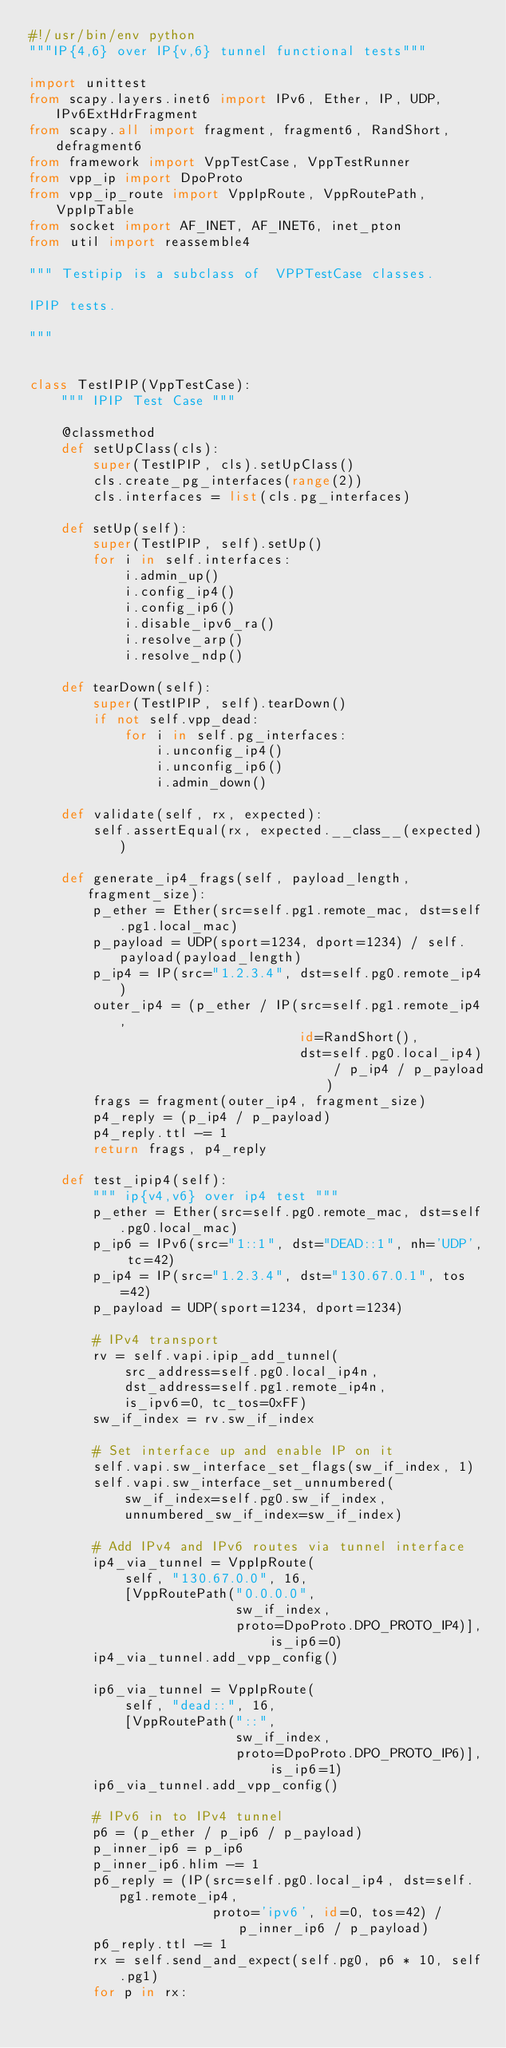<code> <loc_0><loc_0><loc_500><loc_500><_Python_>#!/usr/bin/env python
"""IP{4,6} over IP{v,6} tunnel functional tests"""

import unittest
from scapy.layers.inet6 import IPv6, Ether, IP, UDP, IPv6ExtHdrFragment
from scapy.all import fragment, fragment6, RandShort, defragment6
from framework import VppTestCase, VppTestRunner
from vpp_ip import DpoProto
from vpp_ip_route import VppIpRoute, VppRoutePath, VppIpTable
from socket import AF_INET, AF_INET6, inet_pton
from util import reassemble4

""" Testipip is a subclass of  VPPTestCase classes.

IPIP tests.

"""


class TestIPIP(VppTestCase):
    """ IPIP Test Case """

    @classmethod
    def setUpClass(cls):
        super(TestIPIP, cls).setUpClass()
        cls.create_pg_interfaces(range(2))
        cls.interfaces = list(cls.pg_interfaces)

    def setUp(self):
        super(TestIPIP, self).setUp()
        for i in self.interfaces:
            i.admin_up()
            i.config_ip4()
            i.config_ip6()
            i.disable_ipv6_ra()
            i.resolve_arp()
            i.resolve_ndp()

    def tearDown(self):
        super(TestIPIP, self).tearDown()
        if not self.vpp_dead:
            for i in self.pg_interfaces:
                i.unconfig_ip4()
                i.unconfig_ip6()
                i.admin_down()

    def validate(self, rx, expected):
        self.assertEqual(rx, expected.__class__(expected))

    def generate_ip4_frags(self, payload_length, fragment_size):
        p_ether = Ether(src=self.pg1.remote_mac, dst=self.pg1.local_mac)
        p_payload = UDP(sport=1234, dport=1234) / self.payload(payload_length)
        p_ip4 = IP(src="1.2.3.4", dst=self.pg0.remote_ip4)
        outer_ip4 = (p_ether / IP(src=self.pg1.remote_ip4,
                                  id=RandShort(),
                                  dst=self.pg0.local_ip4) / p_ip4 / p_payload)
        frags = fragment(outer_ip4, fragment_size)
        p4_reply = (p_ip4 / p_payload)
        p4_reply.ttl -= 1
        return frags, p4_reply

    def test_ipip4(self):
        """ ip{v4,v6} over ip4 test """
        p_ether = Ether(src=self.pg0.remote_mac, dst=self.pg0.local_mac)
        p_ip6 = IPv6(src="1::1", dst="DEAD::1", nh='UDP', tc=42)
        p_ip4 = IP(src="1.2.3.4", dst="130.67.0.1", tos=42)
        p_payload = UDP(sport=1234, dport=1234)

        # IPv4 transport
        rv = self.vapi.ipip_add_tunnel(
            src_address=self.pg0.local_ip4n,
            dst_address=self.pg1.remote_ip4n,
            is_ipv6=0, tc_tos=0xFF)
        sw_if_index = rv.sw_if_index

        # Set interface up and enable IP on it
        self.vapi.sw_interface_set_flags(sw_if_index, 1)
        self.vapi.sw_interface_set_unnumbered(
            sw_if_index=self.pg0.sw_if_index,
            unnumbered_sw_if_index=sw_if_index)

        # Add IPv4 and IPv6 routes via tunnel interface
        ip4_via_tunnel = VppIpRoute(
            self, "130.67.0.0", 16,
            [VppRoutePath("0.0.0.0",
                          sw_if_index,
                          proto=DpoProto.DPO_PROTO_IP4)], is_ip6=0)
        ip4_via_tunnel.add_vpp_config()

        ip6_via_tunnel = VppIpRoute(
            self, "dead::", 16,
            [VppRoutePath("::",
                          sw_if_index,
                          proto=DpoProto.DPO_PROTO_IP6)], is_ip6=1)
        ip6_via_tunnel.add_vpp_config()

        # IPv6 in to IPv4 tunnel
        p6 = (p_ether / p_ip6 / p_payload)
        p_inner_ip6 = p_ip6
        p_inner_ip6.hlim -= 1
        p6_reply = (IP(src=self.pg0.local_ip4, dst=self.pg1.remote_ip4,
                       proto='ipv6', id=0, tos=42) / p_inner_ip6 / p_payload)
        p6_reply.ttl -= 1
        rx = self.send_and_expect(self.pg0, p6 * 10, self.pg1)
        for p in rx:</code> 